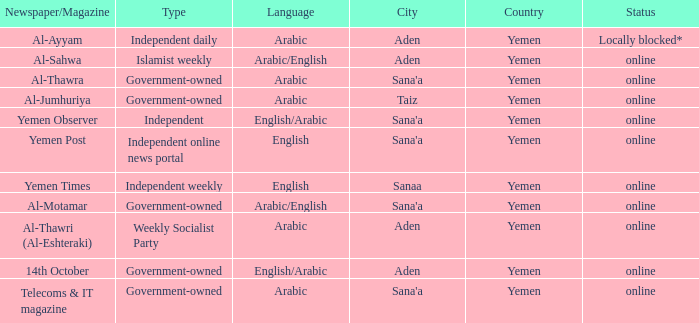Would you be able to parse every entry in this table? {'header': ['Newspaper/Magazine', 'Type', 'Language', 'City', 'Country', 'Status'], 'rows': [['Al-Ayyam', 'Independent daily', 'Arabic', 'Aden', 'Yemen', 'Locally blocked*'], ['Al-Sahwa', 'Islamist weekly', 'Arabic/English', 'Aden', 'Yemen', 'online'], ['Al-Thawra', 'Government-owned', 'Arabic', "Sana'a", 'Yemen', 'online'], ['Al-Jumhuriya', 'Government-owned', 'Arabic', 'Taiz', 'Yemen', 'online'], ['Yemen Observer', 'Independent', 'English/Arabic', "Sana'a", 'Yemen', 'online'], ['Yemen Post', 'Independent online news portal', 'English', "Sana'a", 'Yemen', 'online'], ['Yemen Times', 'Independent weekly', 'English', 'Sanaa', 'Yemen', 'online'], ['Al-Motamar', 'Government-owned', 'Arabic/English', "Sana'a", 'Yemen', 'online'], ['Al-Thawri (Al-Eshteraki)', 'Weekly Socialist Party', 'Arabic', 'Aden', 'Yemen', 'online'], ['14th October', 'Government-owned', 'English/Arabic', 'Aden', 'Yemen', 'online'], ['Telecoms & IT magazine', 'Government-owned', 'Arabic', "Sana'a", 'Yemen', 'online']]} What is Type, when Newspaper/Magazine is Telecoms & It Magazine? Government-owned. 